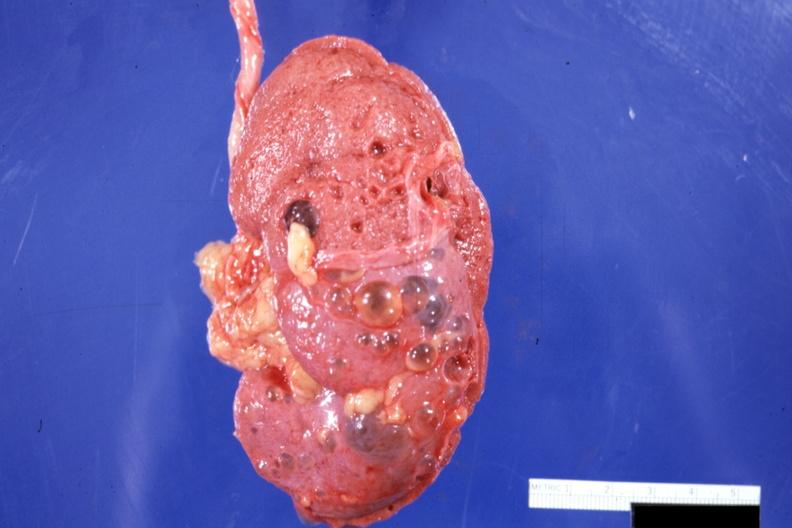does this image show external view with capsule stripped?
Answer the question using a single word or phrase. Yes 